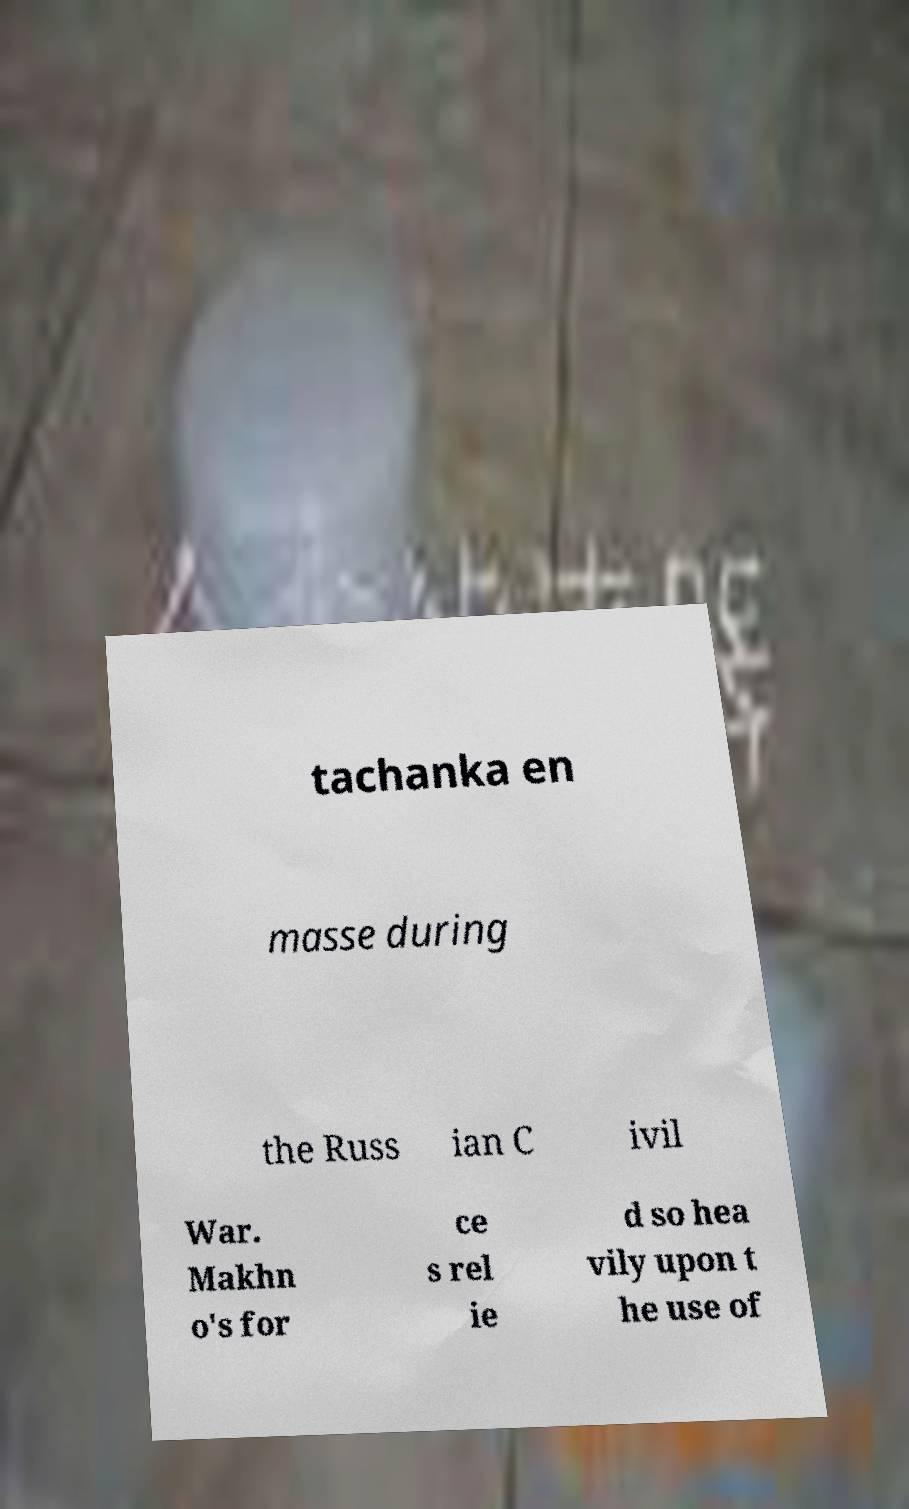Can you accurately transcribe the text from the provided image for me? tachanka en masse during the Russ ian C ivil War. Makhn o's for ce s rel ie d so hea vily upon t he use of 